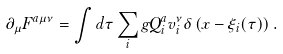<formula> <loc_0><loc_0><loc_500><loc_500>\partial _ { \mu } F ^ { a \mu \nu } = \int d \tau \sum _ { i } g Q _ { i } ^ { a } v _ { i } ^ { \nu } \delta \left ( x - \xi _ { i } ( \tau ) \right ) .</formula> 